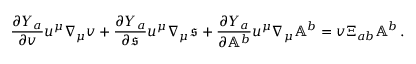<formula> <loc_0><loc_0><loc_500><loc_500>\frac { \partial Y _ { a } } { \partial v } u ^ { \mu } \nabla _ { \mu } v + \frac { \partial Y _ { a } } { \partial \mathfrak { s } } u ^ { \mu } \nabla _ { \mu } \mathfrak { s } + \frac { \partial Y _ { a } } { \partial \mathbb { A } ^ { b } } u ^ { \mu } \nabla _ { \mu } \mathbb { A } ^ { b } = v \Xi _ { a b } \mathbb { A } ^ { b } \, .</formula> 